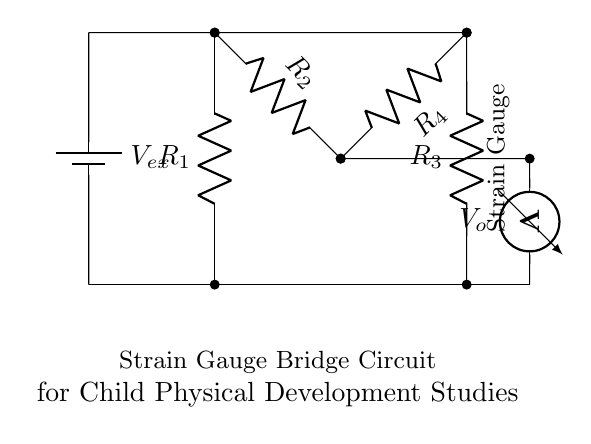What type of circuit is this? This circuit is a bridge circuit, specifically a strain gauge bridge circuit used for measuring small changes in force. It consists of resistors arranged in a diamond shape, with a voltage source and output terminals.
Answer: Bridge circuit What are the components of the bridge? The components are four resistors labelled R1, R2, R3, and R4, a voltage source labelled Vex, and an output measured by a voltmeter labelled Vo.
Answer: R1, R2, R3, R4, Vex, Vo What does the strain gauge measure? The strain gauge measures the change in resistance caused by mechanical deformation when force is applied, translating that into an electrical signal that can be measured.
Answer: Change in resistance What is the role of Vex in the circuit? Vex is the excitation voltage supplied to the bridge circuit, providing the necessary energy for the circuit to operate and enabling the measurement of the output voltage Vo across the strain gauge.
Answer: Excitation voltage How would the output voltage change with increased force? As the force increases, the strain gauge deforms, resulting in a change in resistance and thereby affecting the balance of the bridge circuit. This leads to a change in the output voltage Vo, which can be measured to reflect the change in force.
Answer: It increases What would happen if R2 is increased? Increasing R2 would unbalance the bridge circuit, causing the output voltage Vo to change. This change could be interpreted as a variation in the applied force, assuming the other resistors remain constant. It illustrates how sensitive the system is to changes in resistance.
Answer: Output voltage changes What is the purpose of the voltmeter in this circuit? The voltmeter measures the output voltage Vo, which indicates the unbalance of the bridge circuit due to the strain gauge's response to applied force, providing quantifiable data for physical development studies.
Answer: Measure output voltage 